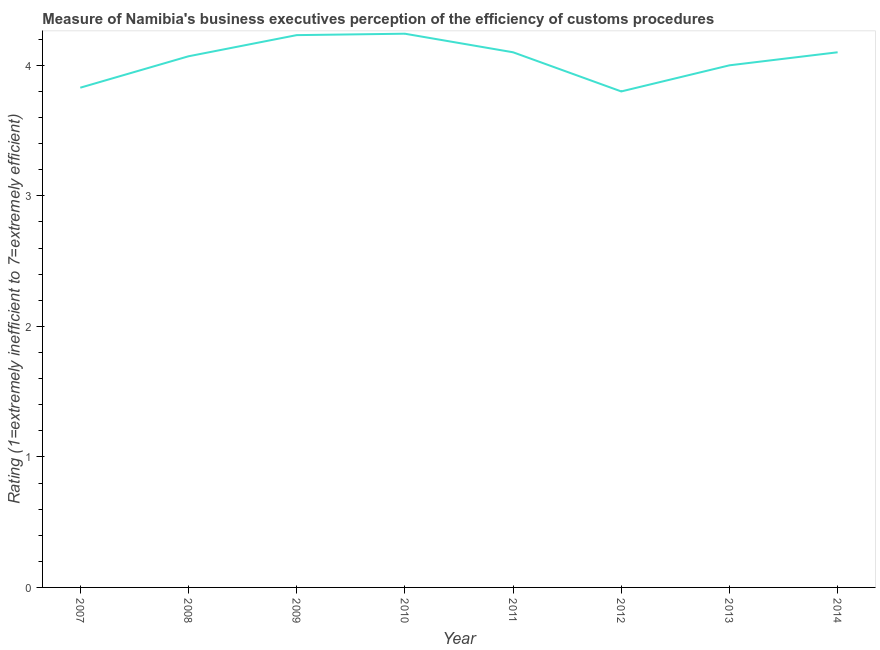What is the rating measuring burden of customs procedure in 2009?
Your answer should be compact. 4.23. Across all years, what is the maximum rating measuring burden of customs procedure?
Your answer should be very brief. 4.24. What is the sum of the rating measuring burden of customs procedure?
Give a very brief answer. 32.37. What is the difference between the rating measuring burden of customs procedure in 2010 and 2013?
Offer a very short reply. 0.24. What is the average rating measuring burden of customs procedure per year?
Provide a succinct answer. 4.05. What is the median rating measuring burden of customs procedure?
Offer a terse response. 4.08. Do a majority of the years between 2007 and 2014 (inclusive) have rating measuring burden of customs procedure greater than 3 ?
Keep it short and to the point. Yes. What is the ratio of the rating measuring burden of customs procedure in 2007 to that in 2012?
Ensure brevity in your answer.  1.01. What is the difference between the highest and the second highest rating measuring burden of customs procedure?
Provide a short and direct response. 0.01. Is the sum of the rating measuring burden of customs procedure in 2007 and 2014 greater than the maximum rating measuring burden of customs procedure across all years?
Provide a short and direct response. Yes. What is the difference between the highest and the lowest rating measuring burden of customs procedure?
Keep it short and to the point. 0.44. Does the rating measuring burden of customs procedure monotonically increase over the years?
Offer a terse response. No. How many lines are there?
Offer a terse response. 1. How many years are there in the graph?
Your answer should be very brief. 8. Are the values on the major ticks of Y-axis written in scientific E-notation?
Your response must be concise. No. Does the graph contain any zero values?
Make the answer very short. No. Does the graph contain grids?
Offer a very short reply. No. What is the title of the graph?
Offer a terse response. Measure of Namibia's business executives perception of the efficiency of customs procedures. What is the label or title of the Y-axis?
Offer a very short reply. Rating (1=extremely inefficient to 7=extremely efficient). What is the Rating (1=extremely inefficient to 7=extremely efficient) of 2007?
Provide a short and direct response. 3.83. What is the Rating (1=extremely inefficient to 7=extremely efficient) of 2008?
Offer a terse response. 4.07. What is the Rating (1=extremely inefficient to 7=extremely efficient) in 2009?
Provide a succinct answer. 4.23. What is the Rating (1=extremely inefficient to 7=extremely efficient) in 2010?
Keep it short and to the point. 4.24. What is the Rating (1=extremely inefficient to 7=extremely efficient) in 2011?
Offer a terse response. 4.1. What is the Rating (1=extremely inefficient to 7=extremely efficient) in 2012?
Offer a very short reply. 3.8. What is the Rating (1=extremely inefficient to 7=extremely efficient) of 2013?
Your answer should be compact. 4. What is the difference between the Rating (1=extremely inefficient to 7=extremely efficient) in 2007 and 2008?
Your answer should be very brief. -0.24. What is the difference between the Rating (1=extremely inefficient to 7=extremely efficient) in 2007 and 2009?
Ensure brevity in your answer.  -0.4. What is the difference between the Rating (1=extremely inefficient to 7=extremely efficient) in 2007 and 2010?
Provide a short and direct response. -0.41. What is the difference between the Rating (1=extremely inefficient to 7=extremely efficient) in 2007 and 2011?
Provide a succinct answer. -0.27. What is the difference between the Rating (1=extremely inefficient to 7=extremely efficient) in 2007 and 2012?
Your answer should be very brief. 0.03. What is the difference between the Rating (1=extremely inefficient to 7=extremely efficient) in 2007 and 2013?
Provide a succinct answer. -0.17. What is the difference between the Rating (1=extremely inefficient to 7=extremely efficient) in 2007 and 2014?
Ensure brevity in your answer.  -0.27. What is the difference between the Rating (1=extremely inefficient to 7=extremely efficient) in 2008 and 2009?
Give a very brief answer. -0.16. What is the difference between the Rating (1=extremely inefficient to 7=extremely efficient) in 2008 and 2010?
Make the answer very short. -0.17. What is the difference between the Rating (1=extremely inefficient to 7=extremely efficient) in 2008 and 2011?
Offer a very short reply. -0.03. What is the difference between the Rating (1=extremely inefficient to 7=extremely efficient) in 2008 and 2012?
Provide a short and direct response. 0.27. What is the difference between the Rating (1=extremely inefficient to 7=extremely efficient) in 2008 and 2013?
Ensure brevity in your answer.  0.07. What is the difference between the Rating (1=extremely inefficient to 7=extremely efficient) in 2008 and 2014?
Ensure brevity in your answer.  -0.03. What is the difference between the Rating (1=extremely inefficient to 7=extremely efficient) in 2009 and 2010?
Provide a short and direct response. -0.01. What is the difference between the Rating (1=extremely inefficient to 7=extremely efficient) in 2009 and 2011?
Ensure brevity in your answer.  0.13. What is the difference between the Rating (1=extremely inefficient to 7=extremely efficient) in 2009 and 2012?
Make the answer very short. 0.43. What is the difference between the Rating (1=extremely inefficient to 7=extremely efficient) in 2009 and 2013?
Your answer should be compact. 0.23. What is the difference between the Rating (1=extremely inefficient to 7=extremely efficient) in 2009 and 2014?
Make the answer very short. 0.13. What is the difference between the Rating (1=extremely inefficient to 7=extremely efficient) in 2010 and 2011?
Provide a short and direct response. 0.14. What is the difference between the Rating (1=extremely inefficient to 7=extremely efficient) in 2010 and 2012?
Offer a terse response. 0.44. What is the difference between the Rating (1=extremely inefficient to 7=extremely efficient) in 2010 and 2013?
Your answer should be very brief. 0.24. What is the difference between the Rating (1=extremely inefficient to 7=extremely efficient) in 2010 and 2014?
Your answer should be very brief. 0.14. What is the difference between the Rating (1=extremely inefficient to 7=extremely efficient) in 2011 and 2012?
Your answer should be very brief. 0.3. What is the ratio of the Rating (1=extremely inefficient to 7=extremely efficient) in 2007 to that in 2008?
Your answer should be compact. 0.94. What is the ratio of the Rating (1=extremely inefficient to 7=extremely efficient) in 2007 to that in 2009?
Make the answer very short. 0.91. What is the ratio of the Rating (1=extremely inefficient to 7=extremely efficient) in 2007 to that in 2010?
Your response must be concise. 0.9. What is the ratio of the Rating (1=extremely inefficient to 7=extremely efficient) in 2007 to that in 2011?
Your answer should be very brief. 0.93. What is the ratio of the Rating (1=extremely inefficient to 7=extremely efficient) in 2007 to that in 2014?
Your response must be concise. 0.93. What is the ratio of the Rating (1=extremely inefficient to 7=extremely efficient) in 2008 to that in 2010?
Give a very brief answer. 0.96. What is the ratio of the Rating (1=extremely inefficient to 7=extremely efficient) in 2008 to that in 2012?
Provide a succinct answer. 1.07. What is the ratio of the Rating (1=extremely inefficient to 7=extremely efficient) in 2008 to that in 2013?
Give a very brief answer. 1.02. What is the ratio of the Rating (1=extremely inefficient to 7=extremely efficient) in 2009 to that in 2011?
Give a very brief answer. 1.03. What is the ratio of the Rating (1=extremely inefficient to 7=extremely efficient) in 2009 to that in 2012?
Give a very brief answer. 1.11. What is the ratio of the Rating (1=extremely inefficient to 7=extremely efficient) in 2009 to that in 2013?
Your response must be concise. 1.06. What is the ratio of the Rating (1=extremely inefficient to 7=extremely efficient) in 2009 to that in 2014?
Give a very brief answer. 1.03. What is the ratio of the Rating (1=extremely inefficient to 7=extremely efficient) in 2010 to that in 2011?
Your response must be concise. 1.03. What is the ratio of the Rating (1=extremely inefficient to 7=extremely efficient) in 2010 to that in 2012?
Give a very brief answer. 1.12. What is the ratio of the Rating (1=extremely inefficient to 7=extremely efficient) in 2010 to that in 2013?
Your answer should be very brief. 1.06. What is the ratio of the Rating (1=extremely inefficient to 7=extremely efficient) in 2010 to that in 2014?
Offer a very short reply. 1.03. What is the ratio of the Rating (1=extremely inefficient to 7=extremely efficient) in 2011 to that in 2012?
Offer a very short reply. 1.08. What is the ratio of the Rating (1=extremely inefficient to 7=extremely efficient) in 2011 to that in 2013?
Your response must be concise. 1.02. What is the ratio of the Rating (1=extremely inefficient to 7=extremely efficient) in 2011 to that in 2014?
Ensure brevity in your answer.  1. What is the ratio of the Rating (1=extremely inefficient to 7=extremely efficient) in 2012 to that in 2014?
Provide a short and direct response. 0.93. What is the ratio of the Rating (1=extremely inefficient to 7=extremely efficient) in 2013 to that in 2014?
Provide a succinct answer. 0.98. 